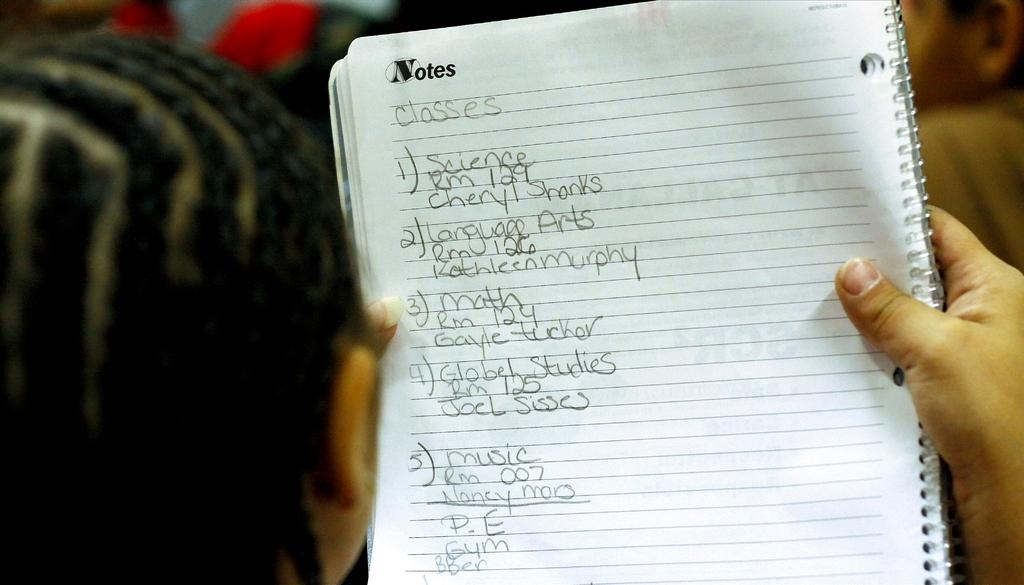<image>
Share a concise interpretation of the image provided. Woman is looking at some notes in a notebook 